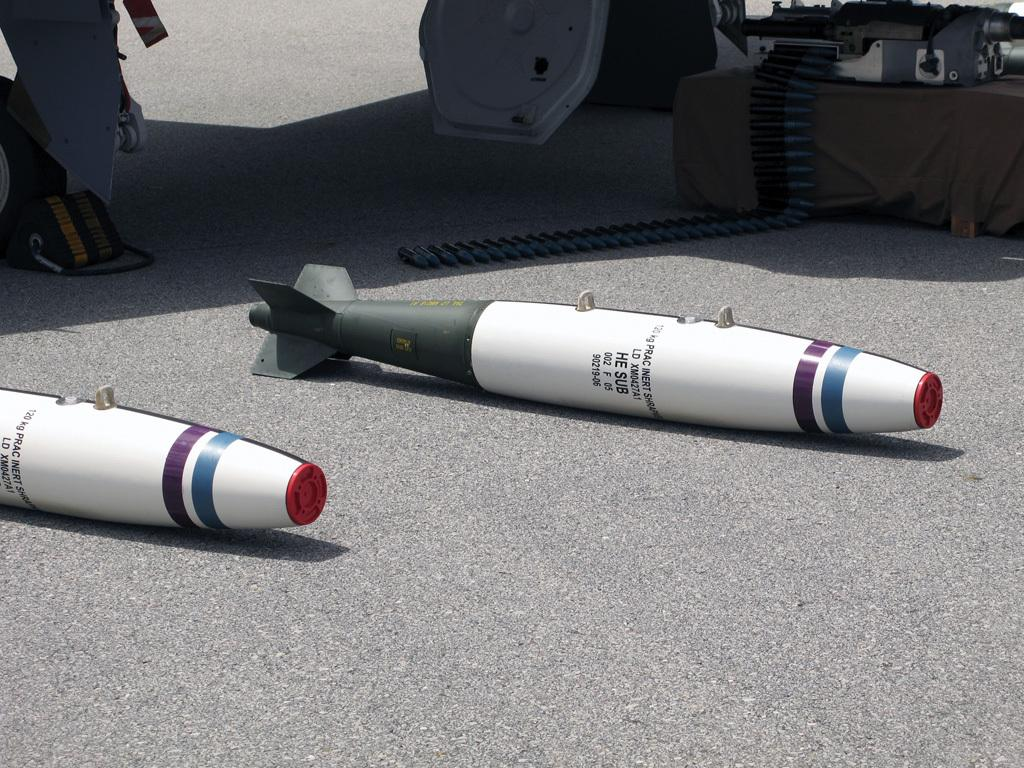What type of weapons are on the floor in the image? There are missiles on the floor in the image. What other ammunition is visible in the image? There are bullets to the right of the missiles. What can be seen at the bottom of the image? There is a road at the bottom of the image. What is located on the road to the left? There are bags on the road to the left. How does the image depict the trade of fuel between countries? The image does not depict any trade or fuel; it features missiles, bullets, a road, and bags. 